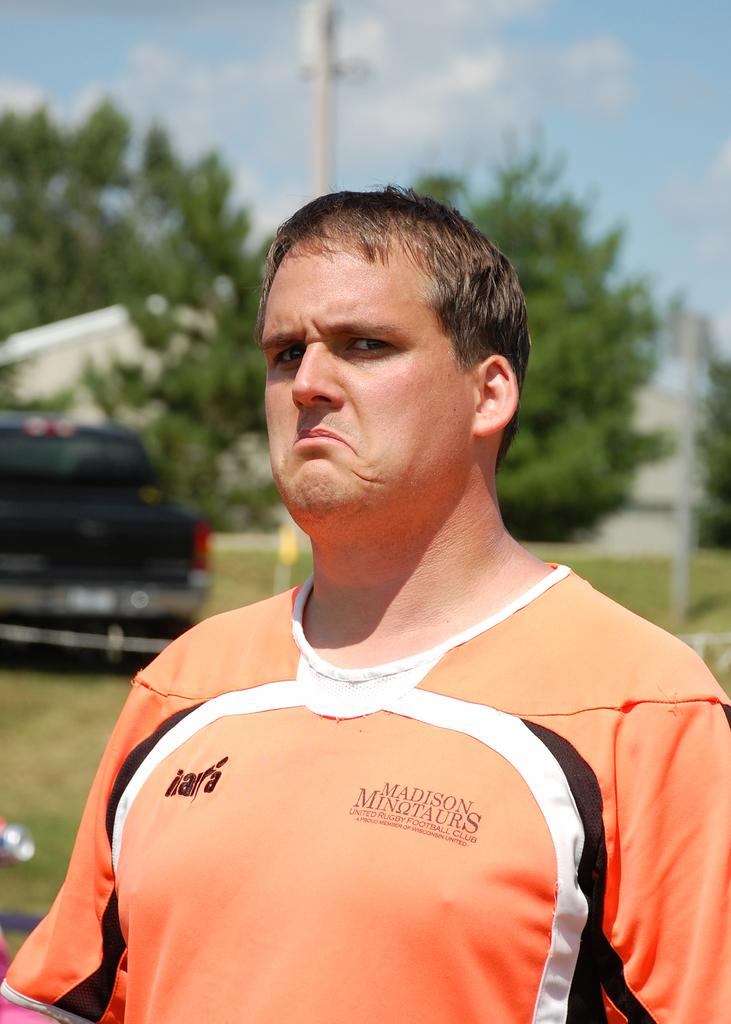Who or what is the main subject in the image? There is a person in the image. What can be seen in the background of the image? There is a vehicle and trees in the background of the image. How would you describe the sky in the image? The sky is blue and cloudy in the image. Can you describe the quality of the background in the image? The background is blurry. What type of polish is being applied to the glass in the image? There is no glass or polish present in the image. 